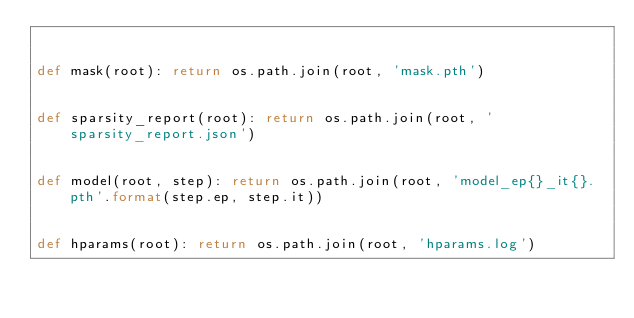<code> <loc_0><loc_0><loc_500><loc_500><_Python_>

def mask(root): return os.path.join(root, 'mask.pth')


def sparsity_report(root): return os.path.join(root, 'sparsity_report.json')


def model(root, step): return os.path.join(root, 'model_ep{}_it{}.pth'.format(step.ep, step.it))


def hparams(root): return os.path.join(root, 'hparams.log')
</code> 